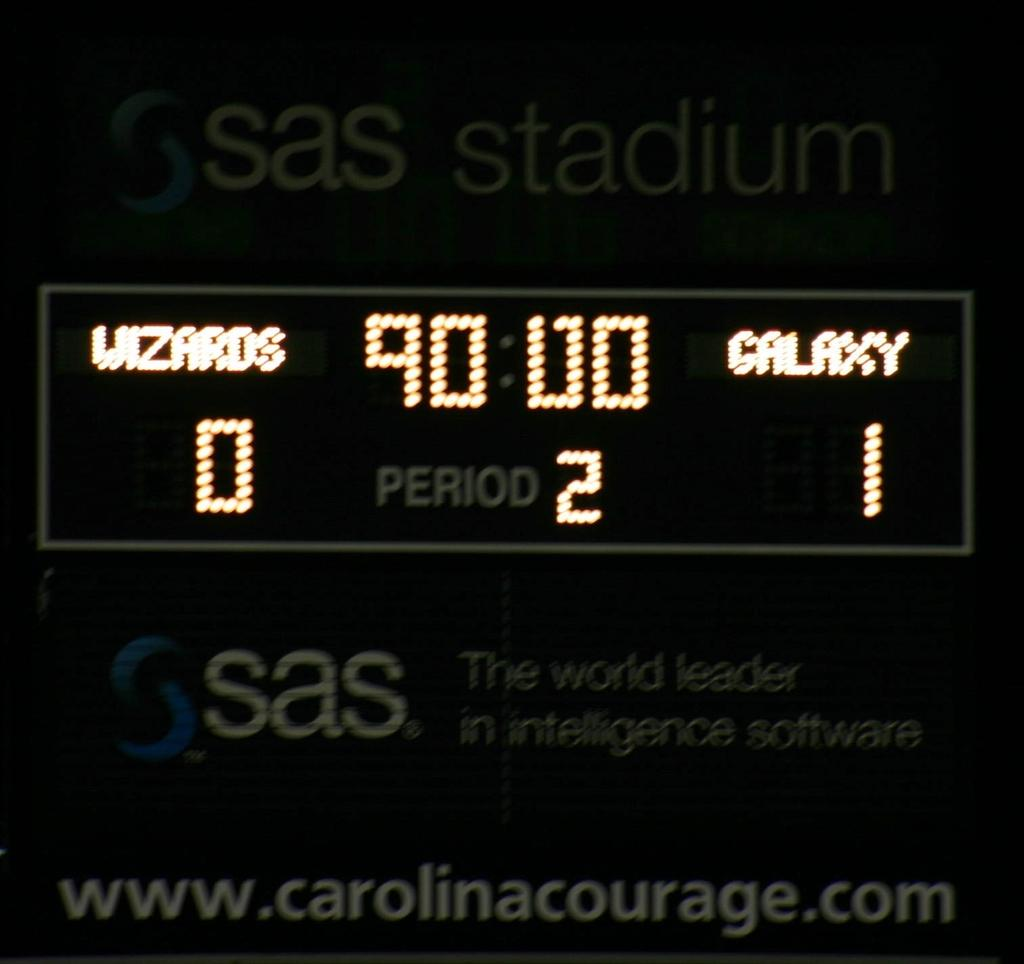What is the main object in the center of the image? There is a screen in the center of the image. What information is displayed on the screen? There are numbers and text on the screen. Can you describe the text at the top of the screen? There is text at the top of the screen. Can you describe the text at the bottom of the screen? There is text at the bottom of the screen. What color is the dress worn by the grape in the image? There is no dress or grape present in the image; it features a screen with numbers and text. 